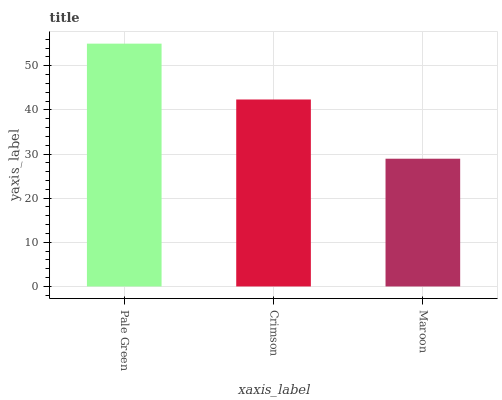Is Maroon the minimum?
Answer yes or no. Yes. Is Pale Green the maximum?
Answer yes or no. Yes. Is Crimson the minimum?
Answer yes or no. No. Is Crimson the maximum?
Answer yes or no. No. Is Pale Green greater than Crimson?
Answer yes or no. Yes. Is Crimson less than Pale Green?
Answer yes or no. Yes. Is Crimson greater than Pale Green?
Answer yes or no. No. Is Pale Green less than Crimson?
Answer yes or no. No. Is Crimson the high median?
Answer yes or no. Yes. Is Crimson the low median?
Answer yes or no. Yes. Is Pale Green the high median?
Answer yes or no. No. Is Pale Green the low median?
Answer yes or no. No. 